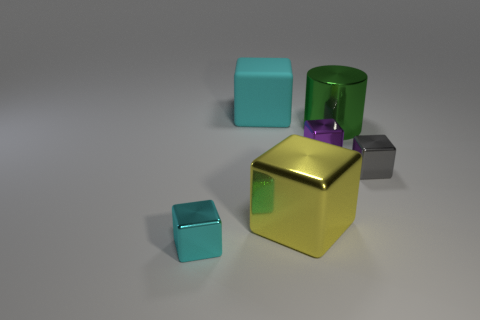Is there any other thing that has the same color as the big cylinder?
Your response must be concise. No. What shape is the large metal thing to the left of the shiny cylinder?
Provide a succinct answer. Cube. There is a metallic object that is behind the tiny gray metal block and on the left side of the green cylinder; what shape is it?
Keep it short and to the point. Cube. What number of yellow objects are metallic cylinders or big blocks?
Offer a terse response. 1. There is a metallic block left of the cyan rubber thing; is it the same color as the big matte object?
Give a very brief answer. Yes. There is a shiny object to the left of the cyan cube behind the tiny cyan metal object; what is its size?
Offer a terse response. Small. There is a cyan cube that is the same size as the gray thing; what is its material?
Offer a very short reply. Metal. How many other objects are there of the same size as the purple cube?
Ensure brevity in your answer.  2. What number of cubes are either small metal things or rubber objects?
Offer a very short reply. 4. Are there any other things that have the same material as the large cyan thing?
Offer a terse response. No. 